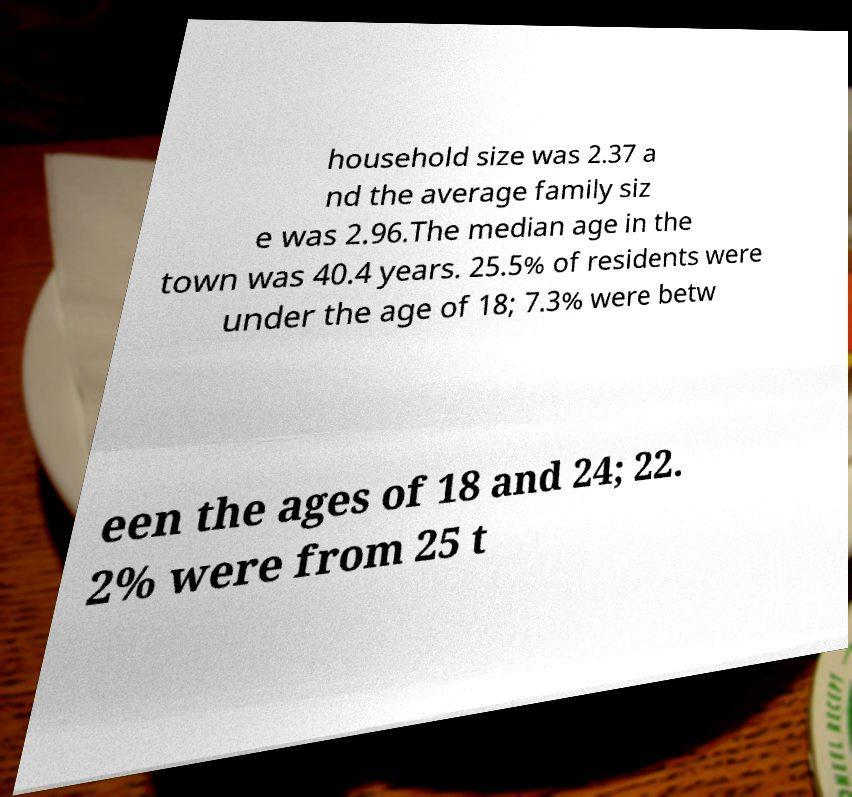Please read and relay the text visible in this image. What does it say? household size was 2.37 a nd the average family siz e was 2.96.The median age in the town was 40.4 years. 25.5% of residents were under the age of 18; 7.3% were betw een the ages of 18 and 24; 22. 2% were from 25 t 